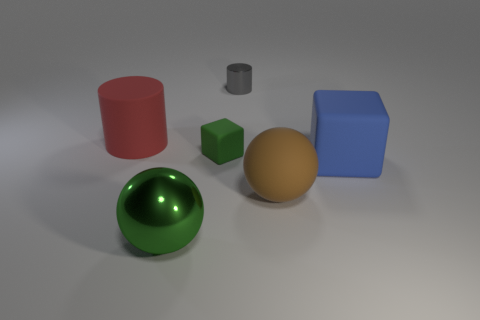There is a big ball that is the same material as the red cylinder; what color is it?
Offer a terse response. Brown. Is the color of the big sphere on the left side of the brown rubber object the same as the large cube?
Your response must be concise. No. There is a large sphere left of the large brown ball; what is its material?
Your response must be concise. Metal. Are there the same number of red cylinders that are in front of the large green sphere and tiny green matte blocks?
Provide a short and direct response. No. What number of tiny blocks have the same color as the shiny sphere?
Keep it short and to the point. 1. There is another shiny object that is the same shape as the large red object; what color is it?
Give a very brief answer. Gray. Do the blue cube and the gray thing have the same size?
Give a very brief answer. No. Are there the same number of red rubber things to the right of the brown rubber thing and big cubes that are to the right of the blue rubber block?
Offer a terse response. Yes. Are any things visible?
Offer a very short reply. Yes. What is the size of the rubber thing that is the same shape as the big green metallic object?
Offer a terse response. Large. 